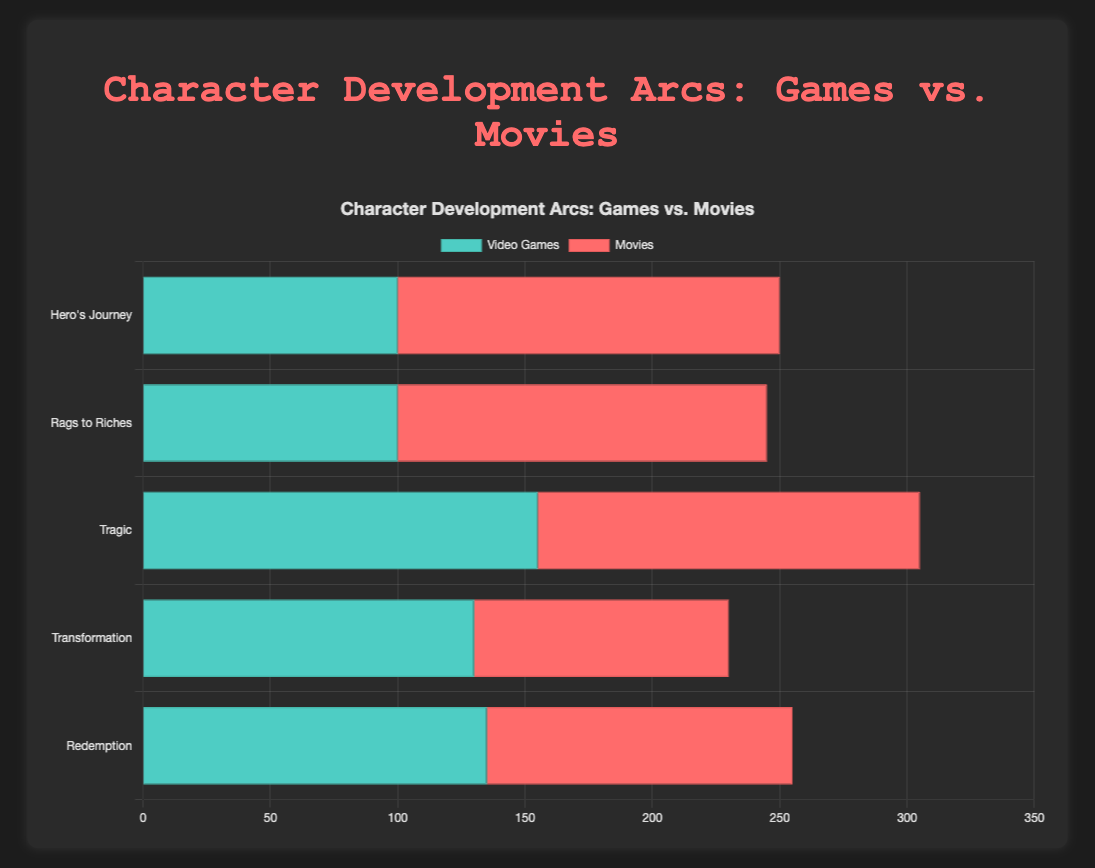How does the representation of the 'Hero's Journey' arc in video games compare to its representation in movies? To compare the representation of the 'Hero's Journey' arc, look at the lengths of the bars for video games and movies. For video games, sum up the values (25 + 20 + 15 + 40 = 100) and compare with movies (35 + 30 + 35 + 50 = 150). This shows movies have a higher representation.
Answer: Movies have a higher representation What is the total representation percentage of the 'Tragic' arc for both video games and movies? For video games, sum the values (35 + 40 + 45 + 35 = 155). For movies, sum the values (30 + 40 + 45 + 35 = 150). Then, calculate the total representation percentage by adding these sums (155 + 150 = 305) and taking percentage parts for both. For video games: (155/305 * 100 ≈ 50.82%), for movies: (150/305 * 100 ≈ 49.18%).
Answer: Video Games: ~50.82%, Movies: ~49.18% Which arc type shows the greatest difference in representation between video games and movies? To determine this, calculate the difference for each arc type between video games and movies, then identify the largest difference. For 'Hero's Journey': 150 - 100 = 50, for 'Rags to Riches': 145 - 100 = 45, for 'Tragic': 150 - 155 = 5, for 'Transformation': 100 - 120 = 20, for 'Redemption': 120 - 125 = 5. Thus, 'Hero's Journey' shows the greatest difference.
Answer: Hero's Journey How do the proportions of 'Redemption' arcs in video games compare to movies? Calculate the total for video games (40 + 45 + 30 + 20 = 135) versus movies (25 + 40 + 45 + 10 = 120). Video games have 135 units, while movies have 120 units. This shows a slightly higher representation in video games.
Answer: Video games have higher representation In which character arc do movies outperform video games the most? To find this, compare each arc's representation in movies against video games and look for the largest positive difference. For 'Hero's Journey', the difference is (150 - 100 = 50), 'Rags to Riches' (145 - 100 = 45), 'Tragic' (150 - 155 = -5), 'Transformation' (120 - 130 = -10), 'Redemption' (120 - 135 = -15). Movies outperform the most in the 'Hero's Journey'.
Answer: Hero's Journey Which arc type has the most balanced representation between video games and movies? Balance refers to the smallest difference in representation. Calculate the differences: 'Hero's Journey' (150 - 100 = 50), 'Rags to Riches' (145 - 100 = 45), 'Tragic' (150 - 155 = 5), 'Transformation' (120 - 130 = 10), 'Redemption' (120 - 135 = 15). 'Tragic' has the smallest difference.
Answer: Tragic What is the sum of the representation percentages for 'Transformation' and 'Redemption' arcs in movies? First, calculate the sums for 'Transformation' (25 + 35 + 30 + 10 = 100) and 'Redemption' (25 + 40 + 45 + 10 = 120) in movies. Add these sums (100 + 120 = 220) and find the total percentage from the movie side (1000). The sum of the percentages is (220/1000 * 100 = 22%).
Answer: 22% 